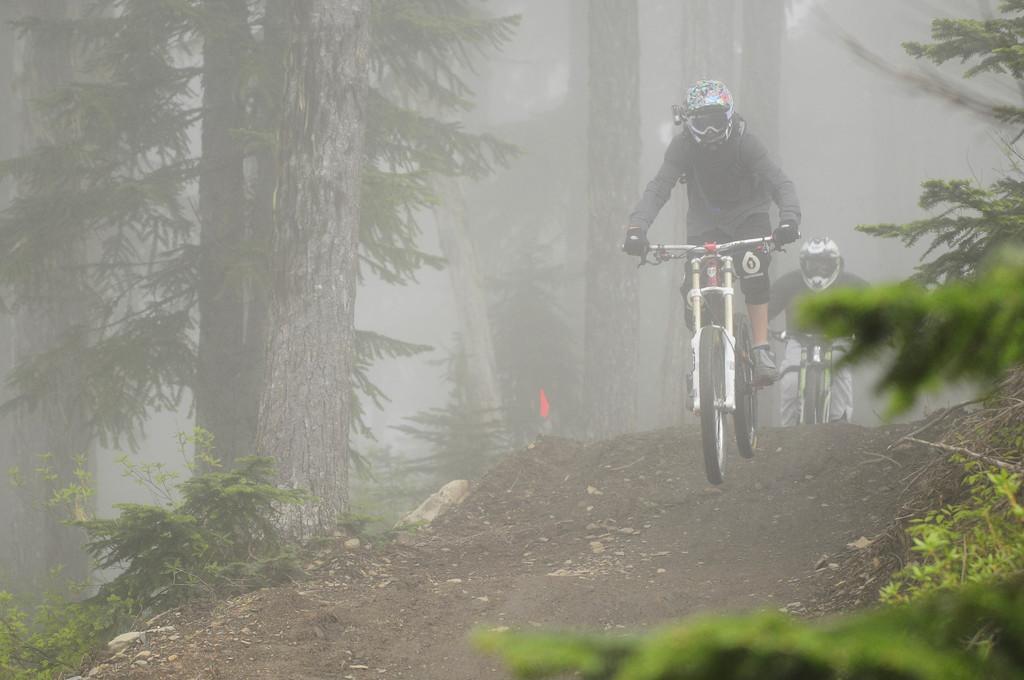Describe this image in one or two sentences. In this image we can see people riding bicycles and there are trees. At the bottom there are plants. 